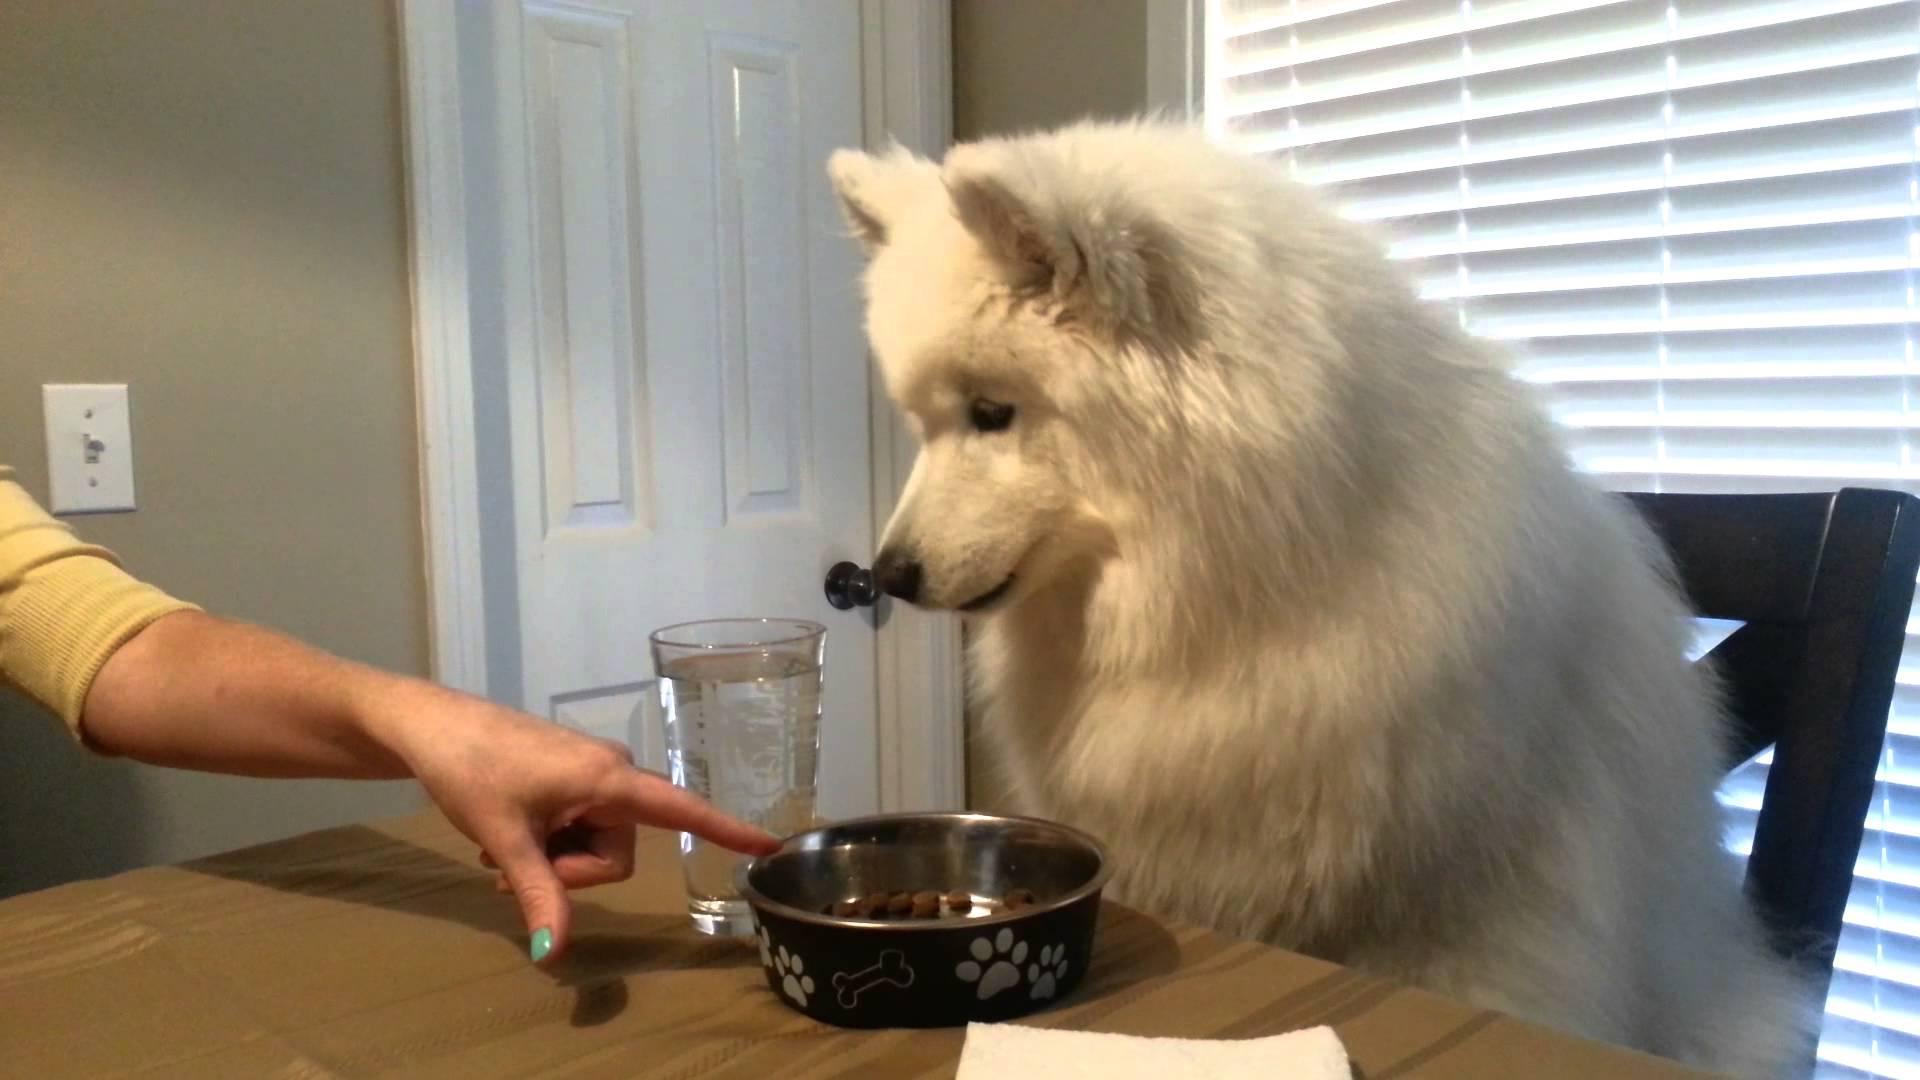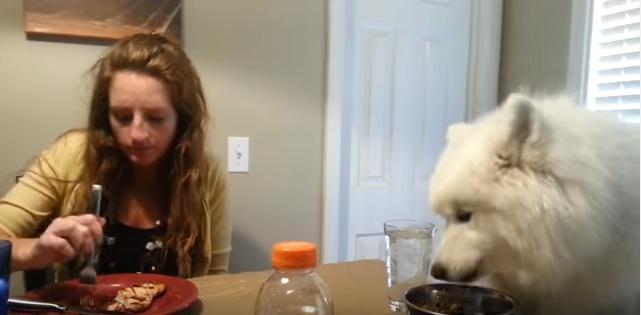The first image is the image on the left, the second image is the image on the right. Evaluate the accuracy of this statement regarding the images: "a dog is sitting at the kitchen table". Is it true? Answer yes or no. Yes. The first image is the image on the left, the second image is the image on the right. Analyze the images presented: Is the assertion "There is a total of 2 Samoyed's sitting at a table." valid? Answer yes or no. Yes. 